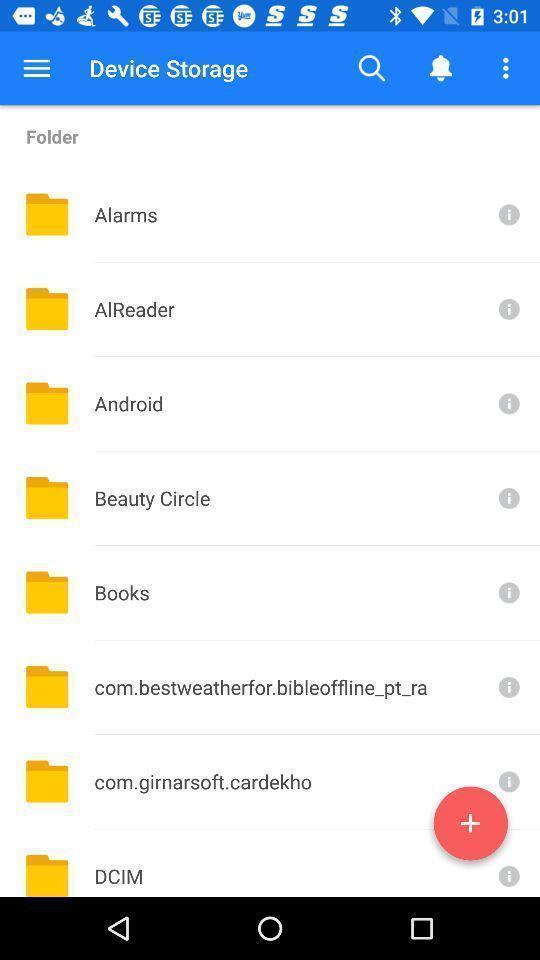What can you discern from this picture? Screen page displaying various folders. 